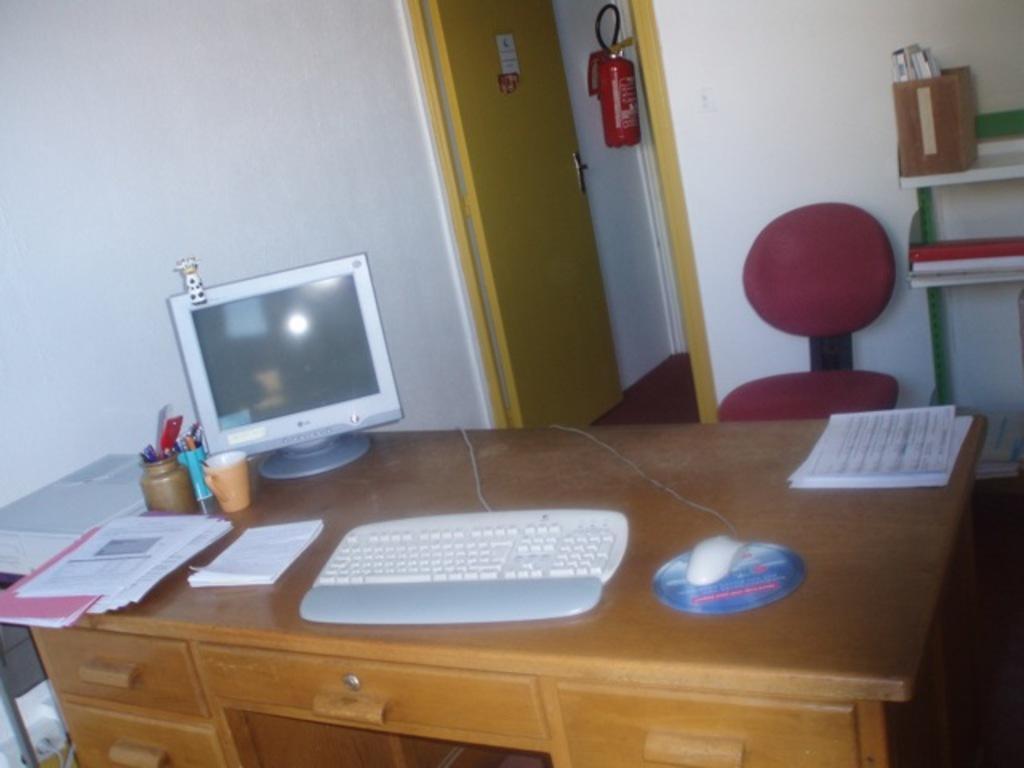Describe this image in one or two sentences. In the image in the center, we can see one table and drawers. On the table, we can see one keyboard, mouse, monitor, cpu, files, papers, jars, pens etc.. In the background there is a wall, door, table, fire extinguisher and books. 